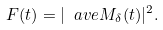Convert formula to latex. <formula><loc_0><loc_0><loc_500><loc_500>F ( t ) = | \ a v e { M _ { \delta } ( t ) } | ^ { 2 } .</formula> 